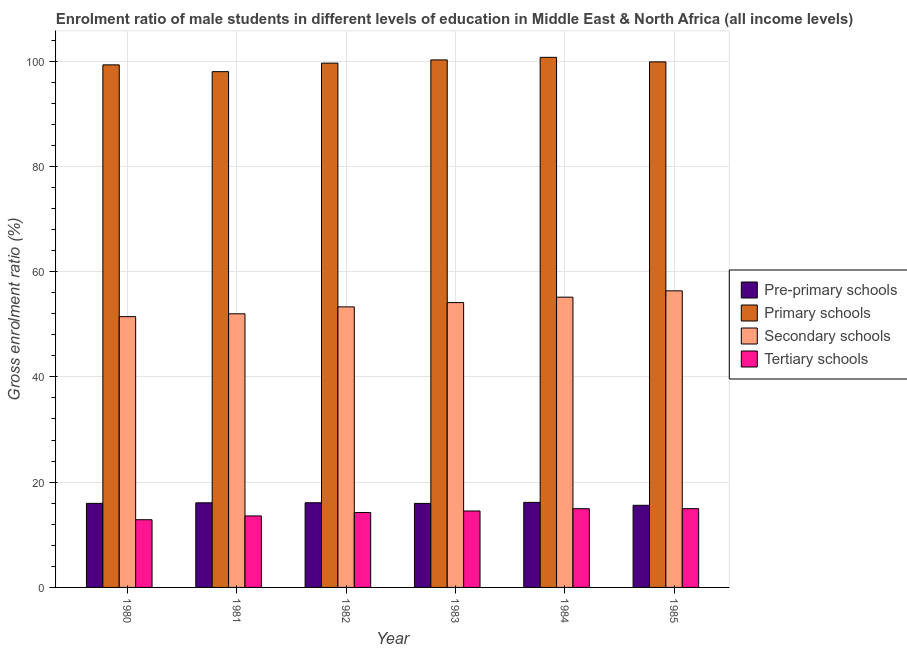How many different coloured bars are there?
Offer a terse response. 4. How many groups of bars are there?
Keep it short and to the point. 6. Are the number of bars on each tick of the X-axis equal?
Ensure brevity in your answer.  Yes. What is the gross enrolment ratio(female) in pre-primary schools in 1983?
Your answer should be very brief. 15.96. Across all years, what is the maximum gross enrolment ratio(female) in secondary schools?
Give a very brief answer. 56.35. Across all years, what is the minimum gross enrolment ratio(female) in pre-primary schools?
Your response must be concise. 15.6. In which year was the gross enrolment ratio(female) in primary schools maximum?
Give a very brief answer. 1984. In which year was the gross enrolment ratio(female) in pre-primary schools minimum?
Your answer should be very brief. 1985. What is the total gross enrolment ratio(female) in tertiary schools in the graph?
Your response must be concise. 85.13. What is the difference between the gross enrolment ratio(female) in tertiary schools in 1983 and that in 1984?
Your answer should be very brief. -0.43. What is the difference between the gross enrolment ratio(female) in tertiary schools in 1981 and the gross enrolment ratio(female) in secondary schools in 1982?
Give a very brief answer. -0.65. What is the average gross enrolment ratio(female) in primary schools per year?
Give a very brief answer. 99.61. In how many years, is the gross enrolment ratio(female) in primary schools greater than 52 %?
Your answer should be very brief. 6. What is the ratio of the gross enrolment ratio(female) in tertiary schools in 1980 to that in 1984?
Keep it short and to the point. 0.86. Is the gross enrolment ratio(female) in primary schools in 1984 less than that in 1985?
Provide a short and direct response. No. Is the difference between the gross enrolment ratio(female) in primary schools in 1983 and 1984 greater than the difference between the gross enrolment ratio(female) in pre-primary schools in 1983 and 1984?
Your response must be concise. No. What is the difference between the highest and the second highest gross enrolment ratio(female) in pre-primary schools?
Keep it short and to the point. 0.07. What is the difference between the highest and the lowest gross enrolment ratio(female) in secondary schools?
Your answer should be compact. 4.9. In how many years, is the gross enrolment ratio(female) in secondary schools greater than the average gross enrolment ratio(female) in secondary schools taken over all years?
Give a very brief answer. 3. Is the sum of the gross enrolment ratio(female) in primary schools in 1981 and 1985 greater than the maximum gross enrolment ratio(female) in tertiary schools across all years?
Provide a short and direct response. Yes. Is it the case that in every year, the sum of the gross enrolment ratio(female) in primary schools and gross enrolment ratio(female) in secondary schools is greater than the sum of gross enrolment ratio(female) in pre-primary schools and gross enrolment ratio(female) in tertiary schools?
Offer a terse response. No. What does the 2nd bar from the left in 1980 represents?
Give a very brief answer. Primary schools. What does the 2nd bar from the right in 1983 represents?
Make the answer very short. Secondary schools. Is it the case that in every year, the sum of the gross enrolment ratio(female) in pre-primary schools and gross enrolment ratio(female) in primary schools is greater than the gross enrolment ratio(female) in secondary schools?
Offer a terse response. Yes. What is the difference between two consecutive major ticks on the Y-axis?
Make the answer very short. 20. Are the values on the major ticks of Y-axis written in scientific E-notation?
Keep it short and to the point. No. Does the graph contain any zero values?
Make the answer very short. No. Where does the legend appear in the graph?
Give a very brief answer. Center right. What is the title of the graph?
Make the answer very short. Enrolment ratio of male students in different levels of education in Middle East & North Africa (all income levels). Does "Quality Certification" appear as one of the legend labels in the graph?
Your response must be concise. No. What is the Gross enrolment ratio (%) of Pre-primary schools in 1980?
Your answer should be compact. 15.97. What is the Gross enrolment ratio (%) in Primary schools in 1980?
Your answer should be very brief. 99.28. What is the Gross enrolment ratio (%) of Secondary schools in 1980?
Keep it short and to the point. 51.45. What is the Gross enrolment ratio (%) in Tertiary schools in 1980?
Provide a succinct answer. 12.86. What is the Gross enrolment ratio (%) of Pre-primary schools in 1981?
Give a very brief answer. 16.08. What is the Gross enrolment ratio (%) in Primary schools in 1981?
Provide a short and direct response. 97.99. What is the Gross enrolment ratio (%) of Secondary schools in 1981?
Keep it short and to the point. 51.98. What is the Gross enrolment ratio (%) in Tertiary schools in 1981?
Your answer should be very brief. 13.59. What is the Gross enrolment ratio (%) of Pre-primary schools in 1982?
Provide a short and direct response. 16.09. What is the Gross enrolment ratio (%) in Primary schools in 1982?
Offer a very short reply. 99.61. What is the Gross enrolment ratio (%) in Secondary schools in 1982?
Your answer should be very brief. 53.3. What is the Gross enrolment ratio (%) of Tertiary schools in 1982?
Provide a short and direct response. 14.24. What is the Gross enrolment ratio (%) of Pre-primary schools in 1983?
Make the answer very short. 15.96. What is the Gross enrolment ratio (%) of Primary schools in 1983?
Keep it short and to the point. 100.22. What is the Gross enrolment ratio (%) of Secondary schools in 1983?
Offer a terse response. 54.11. What is the Gross enrolment ratio (%) of Tertiary schools in 1983?
Give a very brief answer. 14.52. What is the Gross enrolment ratio (%) of Pre-primary schools in 1984?
Provide a short and direct response. 16.16. What is the Gross enrolment ratio (%) of Primary schools in 1984?
Offer a terse response. 100.71. What is the Gross enrolment ratio (%) in Secondary schools in 1984?
Offer a terse response. 55.15. What is the Gross enrolment ratio (%) of Tertiary schools in 1984?
Offer a very short reply. 14.96. What is the Gross enrolment ratio (%) in Pre-primary schools in 1985?
Keep it short and to the point. 15.6. What is the Gross enrolment ratio (%) of Primary schools in 1985?
Your response must be concise. 99.85. What is the Gross enrolment ratio (%) in Secondary schools in 1985?
Offer a terse response. 56.35. What is the Gross enrolment ratio (%) of Tertiary schools in 1985?
Offer a terse response. 14.96. Across all years, what is the maximum Gross enrolment ratio (%) in Pre-primary schools?
Ensure brevity in your answer.  16.16. Across all years, what is the maximum Gross enrolment ratio (%) in Primary schools?
Your answer should be compact. 100.71. Across all years, what is the maximum Gross enrolment ratio (%) of Secondary schools?
Give a very brief answer. 56.35. Across all years, what is the maximum Gross enrolment ratio (%) in Tertiary schools?
Your answer should be very brief. 14.96. Across all years, what is the minimum Gross enrolment ratio (%) in Pre-primary schools?
Keep it short and to the point. 15.6. Across all years, what is the minimum Gross enrolment ratio (%) of Primary schools?
Provide a succinct answer. 97.99. Across all years, what is the minimum Gross enrolment ratio (%) in Secondary schools?
Give a very brief answer. 51.45. Across all years, what is the minimum Gross enrolment ratio (%) of Tertiary schools?
Give a very brief answer. 12.86. What is the total Gross enrolment ratio (%) of Pre-primary schools in the graph?
Your answer should be very brief. 95.86. What is the total Gross enrolment ratio (%) of Primary schools in the graph?
Keep it short and to the point. 597.67. What is the total Gross enrolment ratio (%) in Secondary schools in the graph?
Offer a very short reply. 322.34. What is the total Gross enrolment ratio (%) of Tertiary schools in the graph?
Provide a short and direct response. 85.13. What is the difference between the Gross enrolment ratio (%) of Pre-primary schools in 1980 and that in 1981?
Your response must be concise. -0.1. What is the difference between the Gross enrolment ratio (%) in Primary schools in 1980 and that in 1981?
Offer a very short reply. 1.29. What is the difference between the Gross enrolment ratio (%) of Secondary schools in 1980 and that in 1981?
Offer a terse response. -0.54. What is the difference between the Gross enrolment ratio (%) in Tertiary schools in 1980 and that in 1981?
Provide a short and direct response. -0.72. What is the difference between the Gross enrolment ratio (%) in Pre-primary schools in 1980 and that in 1982?
Keep it short and to the point. -0.12. What is the difference between the Gross enrolment ratio (%) in Primary schools in 1980 and that in 1982?
Offer a very short reply. -0.33. What is the difference between the Gross enrolment ratio (%) in Secondary schools in 1980 and that in 1982?
Your response must be concise. -1.85. What is the difference between the Gross enrolment ratio (%) in Tertiary schools in 1980 and that in 1982?
Make the answer very short. -1.37. What is the difference between the Gross enrolment ratio (%) of Pre-primary schools in 1980 and that in 1983?
Give a very brief answer. 0.01. What is the difference between the Gross enrolment ratio (%) of Primary schools in 1980 and that in 1983?
Your answer should be compact. -0.94. What is the difference between the Gross enrolment ratio (%) in Secondary schools in 1980 and that in 1983?
Provide a short and direct response. -2.67. What is the difference between the Gross enrolment ratio (%) of Tertiary schools in 1980 and that in 1983?
Keep it short and to the point. -1.66. What is the difference between the Gross enrolment ratio (%) in Pre-primary schools in 1980 and that in 1984?
Give a very brief answer. -0.19. What is the difference between the Gross enrolment ratio (%) of Primary schools in 1980 and that in 1984?
Offer a very short reply. -1.43. What is the difference between the Gross enrolment ratio (%) in Secondary schools in 1980 and that in 1984?
Keep it short and to the point. -3.7. What is the difference between the Gross enrolment ratio (%) in Tertiary schools in 1980 and that in 1984?
Offer a very short reply. -2.09. What is the difference between the Gross enrolment ratio (%) in Pre-primary schools in 1980 and that in 1985?
Provide a short and direct response. 0.37. What is the difference between the Gross enrolment ratio (%) of Primary schools in 1980 and that in 1985?
Make the answer very short. -0.57. What is the difference between the Gross enrolment ratio (%) of Secondary schools in 1980 and that in 1985?
Offer a terse response. -4.9. What is the difference between the Gross enrolment ratio (%) in Tertiary schools in 1980 and that in 1985?
Your response must be concise. -2.1. What is the difference between the Gross enrolment ratio (%) in Pre-primary schools in 1981 and that in 1982?
Provide a short and direct response. -0.01. What is the difference between the Gross enrolment ratio (%) of Primary schools in 1981 and that in 1982?
Provide a short and direct response. -1.62. What is the difference between the Gross enrolment ratio (%) in Secondary schools in 1981 and that in 1982?
Provide a succinct answer. -1.32. What is the difference between the Gross enrolment ratio (%) of Tertiary schools in 1981 and that in 1982?
Ensure brevity in your answer.  -0.65. What is the difference between the Gross enrolment ratio (%) of Pre-primary schools in 1981 and that in 1983?
Keep it short and to the point. 0.11. What is the difference between the Gross enrolment ratio (%) of Primary schools in 1981 and that in 1983?
Keep it short and to the point. -2.23. What is the difference between the Gross enrolment ratio (%) of Secondary schools in 1981 and that in 1983?
Provide a short and direct response. -2.13. What is the difference between the Gross enrolment ratio (%) of Tertiary schools in 1981 and that in 1983?
Your answer should be very brief. -0.94. What is the difference between the Gross enrolment ratio (%) in Pre-primary schools in 1981 and that in 1984?
Give a very brief answer. -0.08. What is the difference between the Gross enrolment ratio (%) of Primary schools in 1981 and that in 1984?
Ensure brevity in your answer.  -2.72. What is the difference between the Gross enrolment ratio (%) of Secondary schools in 1981 and that in 1984?
Give a very brief answer. -3.16. What is the difference between the Gross enrolment ratio (%) of Tertiary schools in 1981 and that in 1984?
Make the answer very short. -1.37. What is the difference between the Gross enrolment ratio (%) of Pre-primary schools in 1981 and that in 1985?
Offer a very short reply. 0.47. What is the difference between the Gross enrolment ratio (%) of Primary schools in 1981 and that in 1985?
Your answer should be compact. -1.86. What is the difference between the Gross enrolment ratio (%) in Secondary schools in 1981 and that in 1985?
Ensure brevity in your answer.  -4.37. What is the difference between the Gross enrolment ratio (%) of Tertiary schools in 1981 and that in 1985?
Provide a succinct answer. -1.38. What is the difference between the Gross enrolment ratio (%) of Pre-primary schools in 1982 and that in 1983?
Ensure brevity in your answer.  0.13. What is the difference between the Gross enrolment ratio (%) of Primary schools in 1982 and that in 1983?
Give a very brief answer. -0.61. What is the difference between the Gross enrolment ratio (%) in Secondary schools in 1982 and that in 1983?
Keep it short and to the point. -0.81. What is the difference between the Gross enrolment ratio (%) of Tertiary schools in 1982 and that in 1983?
Make the answer very short. -0.28. What is the difference between the Gross enrolment ratio (%) in Pre-primary schools in 1982 and that in 1984?
Provide a short and direct response. -0.07. What is the difference between the Gross enrolment ratio (%) in Primary schools in 1982 and that in 1984?
Provide a succinct answer. -1.1. What is the difference between the Gross enrolment ratio (%) of Secondary schools in 1982 and that in 1984?
Offer a very short reply. -1.85. What is the difference between the Gross enrolment ratio (%) in Tertiary schools in 1982 and that in 1984?
Make the answer very short. -0.72. What is the difference between the Gross enrolment ratio (%) in Pre-primary schools in 1982 and that in 1985?
Offer a terse response. 0.48. What is the difference between the Gross enrolment ratio (%) in Primary schools in 1982 and that in 1985?
Give a very brief answer. -0.24. What is the difference between the Gross enrolment ratio (%) in Secondary schools in 1982 and that in 1985?
Offer a terse response. -3.05. What is the difference between the Gross enrolment ratio (%) in Tertiary schools in 1982 and that in 1985?
Your answer should be compact. -0.73. What is the difference between the Gross enrolment ratio (%) of Pre-primary schools in 1983 and that in 1984?
Make the answer very short. -0.2. What is the difference between the Gross enrolment ratio (%) in Primary schools in 1983 and that in 1984?
Make the answer very short. -0.49. What is the difference between the Gross enrolment ratio (%) in Secondary schools in 1983 and that in 1984?
Provide a short and direct response. -1.03. What is the difference between the Gross enrolment ratio (%) of Tertiary schools in 1983 and that in 1984?
Make the answer very short. -0.43. What is the difference between the Gross enrolment ratio (%) in Pre-primary schools in 1983 and that in 1985?
Keep it short and to the point. 0.36. What is the difference between the Gross enrolment ratio (%) in Primary schools in 1983 and that in 1985?
Ensure brevity in your answer.  0.37. What is the difference between the Gross enrolment ratio (%) of Secondary schools in 1983 and that in 1985?
Offer a very short reply. -2.24. What is the difference between the Gross enrolment ratio (%) of Tertiary schools in 1983 and that in 1985?
Offer a very short reply. -0.44. What is the difference between the Gross enrolment ratio (%) of Pre-primary schools in 1984 and that in 1985?
Your answer should be compact. 0.56. What is the difference between the Gross enrolment ratio (%) of Primary schools in 1984 and that in 1985?
Provide a succinct answer. 0.86. What is the difference between the Gross enrolment ratio (%) of Secondary schools in 1984 and that in 1985?
Your response must be concise. -1.2. What is the difference between the Gross enrolment ratio (%) of Tertiary schools in 1984 and that in 1985?
Provide a succinct answer. -0.01. What is the difference between the Gross enrolment ratio (%) in Pre-primary schools in 1980 and the Gross enrolment ratio (%) in Primary schools in 1981?
Keep it short and to the point. -82.02. What is the difference between the Gross enrolment ratio (%) of Pre-primary schools in 1980 and the Gross enrolment ratio (%) of Secondary schools in 1981?
Offer a terse response. -36.01. What is the difference between the Gross enrolment ratio (%) in Pre-primary schools in 1980 and the Gross enrolment ratio (%) in Tertiary schools in 1981?
Keep it short and to the point. 2.39. What is the difference between the Gross enrolment ratio (%) of Primary schools in 1980 and the Gross enrolment ratio (%) of Secondary schools in 1981?
Your response must be concise. 47.3. What is the difference between the Gross enrolment ratio (%) of Primary schools in 1980 and the Gross enrolment ratio (%) of Tertiary schools in 1981?
Your response must be concise. 85.69. What is the difference between the Gross enrolment ratio (%) in Secondary schools in 1980 and the Gross enrolment ratio (%) in Tertiary schools in 1981?
Make the answer very short. 37.86. What is the difference between the Gross enrolment ratio (%) in Pre-primary schools in 1980 and the Gross enrolment ratio (%) in Primary schools in 1982?
Your response must be concise. -83.64. What is the difference between the Gross enrolment ratio (%) of Pre-primary schools in 1980 and the Gross enrolment ratio (%) of Secondary schools in 1982?
Provide a succinct answer. -37.33. What is the difference between the Gross enrolment ratio (%) in Pre-primary schools in 1980 and the Gross enrolment ratio (%) in Tertiary schools in 1982?
Your answer should be compact. 1.73. What is the difference between the Gross enrolment ratio (%) in Primary schools in 1980 and the Gross enrolment ratio (%) in Secondary schools in 1982?
Provide a succinct answer. 45.98. What is the difference between the Gross enrolment ratio (%) in Primary schools in 1980 and the Gross enrolment ratio (%) in Tertiary schools in 1982?
Ensure brevity in your answer.  85.04. What is the difference between the Gross enrolment ratio (%) in Secondary schools in 1980 and the Gross enrolment ratio (%) in Tertiary schools in 1982?
Your response must be concise. 37.21. What is the difference between the Gross enrolment ratio (%) of Pre-primary schools in 1980 and the Gross enrolment ratio (%) of Primary schools in 1983?
Keep it short and to the point. -84.25. What is the difference between the Gross enrolment ratio (%) in Pre-primary schools in 1980 and the Gross enrolment ratio (%) in Secondary schools in 1983?
Your answer should be compact. -38.14. What is the difference between the Gross enrolment ratio (%) of Pre-primary schools in 1980 and the Gross enrolment ratio (%) of Tertiary schools in 1983?
Keep it short and to the point. 1.45. What is the difference between the Gross enrolment ratio (%) of Primary schools in 1980 and the Gross enrolment ratio (%) of Secondary schools in 1983?
Your answer should be very brief. 45.17. What is the difference between the Gross enrolment ratio (%) in Primary schools in 1980 and the Gross enrolment ratio (%) in Tertiary schools in 1983?
Your answer should be very brief. 84.76. What is the difference between the Gross enrolment ratio (%) of Secondary schools in 1980 and the Gross enrolment ratio (%) of Tertiary schools in 1983?
Ensure brevity in your answer.  36.92. What is the difference between the Gross enrolment ratio (%) of Pre-primary schools in 1980 and the Gross enrolment ratio (%) of Primary schools in 1984?
Make the answer very short. -84.74. What is the difference between the Gross enrolment ratio (%) in Pre-primary schools in 1980 and the Gross enrolment ratio (%) in Secondary schools in 1984?
Ensure brevity in your answer.  -39.18. What is the difference between the Gross enrolment ratio (%) in Pre-primary schools in 1980 and the Gross enrolment ratio (%) in Tertiary schools in 1984?
Provide a succinct answer. 1.01. What is the difference between the Gross enrolment ratio (%) in Primary schools in 1980 and the Gross enrolment ratio (%) in Secondary schools in 1984?
Provide a succinct answer. 44.13. What is the difference between the Gross enrolment ratio (%) in Primary schools in 1980 and the Gross enrolment ratio (%) in Tertiary schools in 1984?
Provide a succinct answer. 84.32. What is the difference between the Gross enrolment ratio (%) of Secondary schools in 1980 and the Gross enrolment ratio (%) of Tertiary schools in 1984?
Your response must be concise. 36.49. What is the difference between the Gross enrolment ratio (%) in Pre-primary schools in 1980 and the Gross enrolment ratio (%) in Primary schools in 1985?
Provide a short and direct response. -83.88. What is the difference between the Gross enrolment ratio (%) of Pre-primary schools in 1980 and the Gross enrolment ratio (%) of Secondary schools in 1985?
Your response must be concise. -40.38. What is the difference between the Gross enrolment ratio (%) in Pre-primary schools in 1980 and the Gross enrolment ratio (%) in Tertiary schools in 1985?
Your response must be concise. 1.01. What is the difference between the Gross enrolment ratio (%) of Primary schools in 1980 and the Gross enrolment ratio (%) of Secondary schools in 1985?
Make the answer very short. 42.93. What is the difference between the Gross enrolment ratio (%) in Primary schools in 1980 and the Gross enrolment ratio (%) in Tertiary schools in 1985?
Your response must be concise. 84.32. What is the difference between the Gross enrolment ratio (%) of Secondary schools in 1980 and the Gross enrolment ratio (%) of Tertiary schools in 1985?
Make the answer very short. 36.48. What is the difference between the Gross enrolment ratio (%) in Pre-primary schools in 1981 and the Gross enrolment ratio (%) in Primary schools in 1982?
Your response must be concise. -83.53. What is the difference between the Gross enrolment ratio (%) in Pre-primary schools in 1981 and the Gross enrolment ratio (%) in Secondary schools in 1982?
Ensure brevity in your answer.  -37.22. What is the difference between the Gross enrolment ratio (%) in Pre-primary schools in 1981 and the Gross enrolment ratio (%) in Tertiary schools in 1982?
Keep it short and to the point. 1.84. What is the difference between the Gross enrolment ratio (%) of Primary schools in 1981 and the Gross enrolment ratio (%) of Secondary schools in 1982?
Your answer should be very brief. 44.69. What is the difference between the Gross enrolment ratio (%) in Primary schools in 1981 and the Gross enrolment ratio (%) in Tertiary schools in 1982?
Your answer should be compact. 83.75. What is the difference between the Gross enrolment ratio (%) of Secondary schools in 1981 and the Gross enrolment ratio (%) of Tertiary schools in 1982?
Provide a succinct answer. 37.75. What is the difference between the Gross enrolment ratio (%) in Pre-primary schools in 1981 and the Gross enrolment ratio (%) in Primary schools in 1983?
Your response must be concise. -84.15. What is the difference between the Gross enrolment ratio (%) of Pre-primary schools in 1981 and the Gross enrolment ratio (%) of Secondary schools in 1983?
Your answer should be compact. -38.04. What is the difference between the Gross enrolment ratio (%) in Pre-primary schools in 1981 and the Gross enrolment ratio (%) in Tertiary schools in 1983?
Your answer should be compact. 1.55. What is the difference between the Gross enrolment ratio (%) of Primary schools in 1981 and the Gross enrolment ratio (%) of Secondary schools in 1983?
Offer a terse response. 43.88. What is the difference between the Gross enrolment ratio (%) of Primary schools in 1981 and the Gross enrolment ratio (%) of Tertiary schools in 1983?
Offer a terse response. 83.47. What is the difference between the Gross enrolment ratio (%) in Secondary schools in 1981 and the Gross enrolment ratio (%) in Tertiary schools in 1983?
Give a very brief answer. 37.46. What is the difference between the Gross enrolment ratio (%) in Pre-primary schools in 1981 and the Gross enrolment ratio (%) in Primary schools in 1984?
Provide a succinct answer. -84.64. What is the difference between the Gross enrolment ratio (%) in Pre-primary schools in 1981 and the Gross enrolment ratio (%) in Secondary schools in 1984?
Keep it short and to the point. -39.07. What is the difference between the Gross enrolment ratio (%) of Pre-primary schools in 1981 and the Gross enrolment ratio (%) of Tertiary schools in 1984?
Your answer should be very brief. 1.12. What is the difference between the Gross enrolment ratio (%) in Primary schools in 1981 and the Gross enrolment ratio (%) in Secondary schools in 1984?
Provide a short and direct response. 42.84. What is the difference between the Gross enrolment ratio (%) in Primary schools in 1981 and the Gross enrolment ratio (%) in Tertiary schools in 1984?
Offer a terse response. 83.03. What is the difference between the Gross enrolment ratio (%) in Secondary schools in 1981 and the Gross enrolment ratio (%) in Tertiary schools in 1984?
Provide a succinct answer. 37.03. What is the difference between the Gross enrolment ratio (%) of Pre-primary schools in 1981 and the Gross enrolment ratio (%) of Primary schools in 1985?
Your answer should be very brief. -83.77. What is the difference between the Gross enrolment ratio (%) in Pre-primary schools in 1981 and the Gross enrolment ratio (%) in Secondary schools in 1985?
Your answer should be very brief. -40.27. What is the difference between the Gross enrolment ratio (%) in Pre-primary schools in 1981 and the Gross enrolment ratio (%) in Tertiary schools in 1985?
Offer a terse response. 1.11. What is the difference between the Gross enrolment ratio (%) in Primary schools in 1981 and the Gross enrolment ratio (%) in Secondary schools in 1985?
Your answer should be very brief. 41.64. What is the difference between the Gross enrolment ratio (%) in Primary schools in 1981 and the Gross enrolment ratio (%) in Tertiary schools in 1985?
Your response must be concise. 83.03. What is the difference between the Gross enrolment ratio (%) in Secondary schools in 1981 and the Gross enrolment ratio (%) in Tertiary schools in 1985?
Make the answer very short. 37.02. What is the difference between the Gross enrolment ratio (%) in Pre-primary schools in 1982 and the Gross enrolment ratio (%) in Primary schools in 1983?
Offer a very short reply. -84.13. What is the difference between the Gross enrolment ratio (%) in Pre-primary schools in 1982 and the Gross enrolment ratio (%) in Secondary schools in 1983?
Your response must be concise. -38.02. What is the difference between the Gross enrolment ratio (%) of Pre-primary schools in 1982 and the Gross enrolment ratio (%) of Tertiary schools in 1983?
Provide a succinct answer. 1.57. What is the difference between the Gross enrolment ratio (%) of Primary schools in 1982 and the Gross enrolment ratio (%) of Secondary schools in 1983?
Make the answer very short. 45.5. What is the difference between the Gross enrolment ratio (%) of Primary schools in 1982 and the Gross enrolment ratio (%) of Tertiary schools in 1983?
Make the answer very short. 85.09. What is the difference between the Gross enrolment ratio (%) of Secondary schools in 1982 and the Gross enrolment ratio (%) of Tertiary schools in 1983?
Provide a short and direct response. 38.78. What is the difference between the Gross enrolment ratio (%) in Pre-primary schools in 1982 and the Gross enrolment ratio (%) in Primary schools in 1984?
Give a very brief answer. -84.62. What is the difference between the Gross enrolment ratio (%) in Pre-primary schools in 1982 and the Gross enrolment ratio (%) in Secondary schools in 1984?
Give a very brief answer. -39.06. What is the difference between the Gross enrolment ratio (%) in Pre-primary schools in 1982 and the Gross enrolment ratio (%) in Tertiary schools in 1984?
Provide a short and direct response. 1.13. What is the difference between the Gross enrolment ratio (%) of Primary schools in 1982 and the Gross enrolment ratio (%) of Secondary schools in 1984?
Your response must be concise. 44.46. What is the difference between the Gross enrolment ratio (%) in Primary schools in 1982 and the Gross enrolment ratio (%) in Tertiary schools in 1984?
Ensure brevity in your answer.  84.65. What is the difference between the Gross enrolment ratio (%) in Secondary schools in 1982 and the Gross enrolment ratio (%) in Tertiary schools in 1984?
Ensure brevity in your answer.  38.34. What is the difference between the Gross enrolment ratio (%) of Pre-primary schools in 1982 and the Gross enrolment ratio (%) of Primary schools in 1985?
Give a very brief answer. -83.76. What is the difference between the Gross enrolment ratio (%) of Pre-primary schools in 1982 and the Gross enrolment ratio (%) of Secondary schools in 1985?
Your answer should be compact. -40.26. What is the difference between the Gross enrolment ratio (%) in Pre-primary schools in 1982 and the Gross enrolment ratio (%) in Tertiary schools in 1985?
Make the answer very short. 1.13. What is the difference between the Gross enrolment ratio (%) in Primary schools in 1982 and the Gross enrolment ratio (%) in Secondary schools in 1985?
Offer a very short reply. 43.26. What is the difference between the Gross enrolment ratio (%) in Primary schools in 1982 and the Gross enrolment ratio (%) in Tertiary schools in 1985?
Your answer should be very brief. 84.65. What is the difference between the Gross enrolment ratio (%) in Secondary schools in 1982 and the Gross enrolment ratio (%) in Tertiary schools in 1985?
Provide a short and direct response. 38.34. What is the difference between the Gross enrolment ratio (%) in Pre-primary schools in 1983 and the Gross enrolment ratio (%) in Primary schools in 1984?
Your response must be concise. -84.75. What is the difference between the Gross enrolment ratio (%) in Pre-primary schools in 1983 and the Gross enrolment ratio (%) in Secondary schools in 1984?
Your answer should be compact. -39.19. What is the difference between the Gross enrolment ratio (%) of Pre-primary schools in 1983 and the Gross enrolment ratio (%) of Tertiary schools in 1984?
Your response must be concise. 1.01. What is the difference between the Gross enrolment ratio (%) in Primary schools in 1983 and the Gross enrolment ratio (%) in Secondary schools in 1984?
Your response must be concise. 45.08. What is the difference between the Gross enrolment ratio (%) of Primary schools in 1983 and the Gross enrolment ratio (%) of Tertiary schools in 1984?
Provide a succinct answer. 85.27. What is the difference between the Gross enrolment ratio (%) in Secondary schools in 1983 and the Gross enrolment ratio (%) in Tertiary schools in 1984?
Your answer should be very brief. 39.16. What is the difference between the Gross enrolment ratio (%) in Pre-primary schools in 1983 and the Gross enrolment ratio (%) in Primary schools in 1985?
Provide a short and direct response. -83.89. What is the difference between the Gross enrolment ratio (%) of Pre-primary schools in 1983 and the Gross enrolment ratio (%) of Secondary schools in 1985?
Your response must be concise. -40.39. What is the difference between the Gross enrolment ratio (%) in Primary schools in 1983 and the Gross enrolment ratio (%) in Secondary schools in 1985?
Make the answer very short. 43.87. What is the difference between the Gross enrolment ratio (%) in Primary schools in 1983 and the Gross enrolment ratio (%) in Tertiary schools in 1985?
Your answer should be very brief. 85.26. What is the difference between the Gross enrolment ratio (%) of Secondary schools in 1983 and the Gross enrolment ratio (%) of Tertiary schools in 1985?
Give a very brief answer. 39.15. What is the difference between the Gross enrolment ratio (%) of Pre-primary schools in 1984 and the Gross enrolment ratio (%) of Primary schools in 1985?
Give a very brief answer. -83.69. What is the difference between the Gross enrolment ratio (%) of Pre-primary schools in 1984 and the Gross enrolment ratio (%) of Secondary schools in 1985?
Provide a short and direct response. -40.19. What is the difference between the Gross enrolment ratio (%) in Pre-primary schools in 1984 and the Gross enrolment ratio (%) in Tertiary schools in 1985?
Offer a terse response. 1.2. What is the difference between the Gross enrolment ratio (%) in Primary schools in 1984 and the Gross enrolment ratio (%) in Secondary schools in 1985?
Give a very brief answer. 44.36. What is the difference between the Gross enrolment ratio (%) of Primary schools in 1984 and the Gross enrolment ratio (%) of Tertiary schools in 1985?
Your answer should be very brief. 85.75. What is the difference between the Gross enrolment ratio (%) of Secondary schools in 1984 and the Gross enrolment ratio (%) of Tertiary schools in 1985?
Offer a terse response. 40.18. What is the average Gross enrolment ratio (%) in Pre-primary schools per year?
Keep it short and to the point. 15.98. What is the average Gross enrolment ratio (%) of Primary schools per year?
Offer a terse response. 99.61. What is the average Gross enrolment ratio (%) of Secondary schools per year?
Your answer should be very brief. 53.72. What is the average Gross enrolment ratio (%) in Tertiary schools per year?
Keep it short and to the point. 14.19. In the year 1980, what is the difference between the Gross enrolment ratio (%) of Pre-primary schools and Gross enrolment ratio (%) of Primary schools?
Provide a short and direct response. -83.31. In the year 1980, what is the difference between the Gross enrolment ratio (%) of Pre-primary schools and Gross enrolment ratio (%) of Secondary schools?
Your answer should be very brief. -35.47. In the year 1980, what is the difference between the Gross enrolment ratio (%) in Pre-primary schools and Gross enrolment ratio (%) in Tertiary schools?
Provide a short and direct response. 3.11. In the year 1980, what is the difference between the Gross enrolment ratio (%) of Primary schools and Gross enrolment ratio (%) of Secondary schools?
Your answer should be very brief. 47.83. In the year 1980, what is the difference between the Gross enrolment ratio (%) in Primary schools and Gross enrolment ratio (%) in Tertiary schools?
Offer a very short reply. 86.42. In the year 1980, what is the difference between the Gross enrolment ratio (%) in Secondary schools and Gross enrolment ratio (%) in Tertiary schools?
Keep it short and to the point. 38.58. In the year 1981, what is the difference between the Gross enrolment ratio (%) of Pre-primary schools and Gross enrolment ratio (%) of Primary schools?
Give a very brief answer. -81.92. In the year 1981, what is the difference between the Gross enrolment ratio (%) of Pre-primary schools and Gross enrolment ratio (%) of Secondary schools?
Give a very brief answer. -35.91. In the year 1981, what is the difference between the Gross enrolment ratio (%) of Pre-primary schools and Gross enrolment ratio (%) of Tertiary schools?
Keep it short and to the point. 2.49. In the year 1981, what is the difference between the Gross enrolment ratio (%) of Primary schools and Gross enrolment ratio (%) of Secondary schools?
Offer a terse response. 46.01. In the year 1981, what is the difference between the Gross enrolment ratio (%) in Primary schools and Gross enrolment ratio (%) in Tertiary schools?
Your answer should be very brief. 84.41. In the year 1981, what is the difference between the Gross enrolment ratio (%) in Secondary schools and Gross enrolment ratio (%) in Tertiary schools?
Your answer should be very brief. 38.4. In the year 1982, what is the difference between the Gross enrolment ratio (%) of Pre-primary schools and Gross enrolment ratio (%) of Primary schools?
Provide a short and direct response. -83.52. In the year 1982, what is the difference between the Gross enrolment ratio (%) in Pre-primary schools and Gross enrolment ratio (%) in Secondary schools?
Make the answer very short. -37.21. In the year 1982, what is the difference between the Gross enrolment ratio (%) of Pre-primary schools and Gross enrolment ratio (%) of Tertiary schools?
Ensure brevity in your answer.  1.85. In the year 1982, what is the difference between the Gross enrolment ratio (%) of Primary schools and Gross enrolment ratio (%) of Secondary schools?
Ensure brevity in your answer.  46.31. In the year 1982, what is the difference between the Gross enrolment ratio (%) of Primary schools and Gross enrolment ratio (%) of Tertiary schools?
Your answer should be compact. 85.37. In the year 1982, what is the difference between the Gross enrolment ratio (%) in Secondary schools and Gross enrolment ratio (%) in Tertiary schools?
Provide a succinct answer. 39.06. In the year 1983, what is the difference between the Gross enrolment ratio (%) in Pre-primary schools and Gross enrolment ratio (%) in Primary schools?
Offer a terse response. -84.26. In the year 1983, what is the difference between the Gross enrolment ratio (%) of Pre-primary schools and Gross enrolment ratio (%) of Secondary schools?
Make the answer very short. -38.15. In the year 1983, what is the difference between the Gross enrolment ratio (%) of Pre-primary schools and Gross enrolment ratio (%) of Tertiary schools?
Provide a succinct answer. 1.44. In the year 1983, what is the difference between the Gross enrolment ratio (%) of Primary schools and Gross enrolment ratio (%) of Secondary schools?
Your response must be concise. 46.11. In the year 1983, what is the difference between the Gross enrolment ratio (%) in Primary schools and Gross enrolment ratio (%) in Tertiary schools?
Offer a very short reply. 85.7. In the year 1983, what is the difference between the Gross enrolment ratio (%) of Secondary schools and Gross enrolment ratio (%) of Tertiary schools?
Give a very brief answer. 39.59. In the year 1984, what is the difference between the Gross enrolment ratio (%) in Pre-primary schools and Gross enrolment ratio (%) in Primary schools?
Offer a terse response. -84.55. In the year 1984, what is the difference between the Gross enrolment ratio (%) of Pre-primary schools and Gross enrolment ratio (%) of Secondary schools?
Offer a terse response. -38.99. In the year 1984, what is the difference between the Gross enrolment ratio (%) in Pre-primary schools and Gross enrolment ratio (%) in Tertiary schools?
Your answer should be very brief. 1.2. In the year 1984, what is the difference between the Gross enrolment ratio (%) in Primary schools and Gross enrolment ratio (%) in Secondary schools?
Offer a terse response. 45.56. In the year 1984, what is the difference between the Gross enrolment ratio (%) in Primary schools and Gross enrolment ratio (%) in Tertiary schools?
Provide a succinct answer. 85.76. In the year 1984, what is the difference between the Gross enrolment ratio (%) of Secondary schools and Gross enrolment ratio (%) of Tertiary schools?
Provide a succinct answer. 40.19. In the year 1985, what is the difference between the Gross enrolment ratio (%) in Pre-primary schools and Gross enrolment ratio (%) in Primary schools?
Your answer should be very brief. -84.25. In the year 1985, what is the difference between the Gross enrolment ratio (%) in Pre-primary schools and Gross enrolment ratio (%) in Secondary schools?
Offer a very short reply. -40.75. In the year 1985, what is the difference between the Gross enrolment ratio (%) in Pre-primary schools and Gross enrolment ratio (%) in Tertiary schools?
Your answer should be compact. 0.64. In the year 1985, what is the difference between the Gross enrolment ratio (%) in Primary schools and Gross enrolment ratio (%) in Secondary schools?
Give a very brief answer. 43.5. In the year 1985, what is the difference between the Gross enrolment ratio (%) in Primary schools and Gross enrolment ratio (%) in Tertiary schools?
Give a very brief answer. 84.89. In the year 1985, what is the difference between the Gross enrolment ratio (%) of Secondary schools and Gross enrolment ratio (%) of Tertiary schools?
Provide a short and direct response. 41.39. What is the ratio of the Gross enrolment ratio (%) in Primary schools in 1980 to that in 1981?
Your answer should be compact. 1.01. What is the ratio of the Gross enrolment ratio (%) in Tertiary schools in 1980 to that in 1981?
Keep it short and to the point. 0.95. What is the ratio of the Gross enrolment ratio (%) in Secondary schools in 1980 to that in 1982?
Your response must be concise. 0.97. What is the ratio of the Gross enrolment ratio (%) of Tertiary schools in 1980 to that in 1982?
Your response must be concise. 0.9. What is the ratio of the Gross enrolment ratio (%) of Pre-primary schools in 1980 to that in 1983?
Offer a terse response. 1. What is the ratio of the Gross enrolment ratio (%) of Primary schools in 1980 to that in 1983?
Your response must be concise. 0.99. What is the ratio of the Gross enrolment ratio (%) in Secondary schools in 1980 to that in 1983?
Provide a short and direct response. 0.95. What is the ratio of the Gross enrolment ratio (%) in Tertiary schools in 1980 to that in 1983?
Your answer should be very brief. 0.89. What is the ratio of the Gross enrolment ratio (%) of Pre-primary schools in 1980 to that in 1984?
Keep it short and to the point. 0.99. What is the ratio of the Gross enrolment ratio (%) in Primary schools in 1980 to that in 1984?
Your response must be concise. 0.99. What is the ratio of the Gross enrolment ratio (%) of Secondary schools in 1980 to that in 1984?
Make the answer very short. 0.93. What is the ratio of the Gross enrolment ratio (%) in Tertiary schools in 1980 to that in 1984?
Your answer should be compact. 0.86. What is the ratio of the Gross enrolment ratio (%) in Pre-primary schools in 1980 to that in 1985?
Your answer should be compact. 1.02. What is the ratio of the Gross enrolment ratio (%) of Primary schools in 1980 to that in 1985?
Offer a terse response. 0.99. What is the ratio of the Gross enrolment ratio (%) in Tertiary schools in 1980 to that in 1985?
Offer a terse response. 0.86. What is the ratio of the Gross enrolment ratio (%) in Pre-primary schools in 1981 to that in 1982?
Provide a short and direct response. 1. What is the ratio of the Gross enrolment ratio (%) in Primary schools in 1981 to that in 1982?
Offer a terse response. 0.98. What is the ratio of the Gross enrolment ratio (%) in Secondary schools in 1981 to that in 1982?
Provide a short and direct response. 0.98. What is the ratio of the Gross enrolment ratio (%) of Tertiary schools in 1981 to that in 1982?
Your answer should be compact. 0.95. What is the ratio of the Gross enrolment ratio (%) of Pre-primary schools in 1981 to that in 1983?
Offer a terse response. 1.01. What is the ratio of the Gross enrolment ratio (%) of Primary schools in 1981 to that in 1983?
Your answer should be compact. 0.98. What is the ratio of the Gross enrolment ratio (%) in Secondary schools in 1981 to that in 1983?
Provide a succinct answer. 0.96. What is the ratio of the Gross enrolment ratio (%) of Tertiary schools in 1981 to that in 1983?
Your answer should be very brief. 0.94. What is the ratio of the Gross enrolment ratio (%) of Pre-primary schools in 1981 to that in 1984?
Ensure brevity in your answer.  0.99. What is the ratio of the Gross enrolment ratio (%) of Secondary schools in 1981 to that in 1984?
Ensure brevity in your answer.  0.94. What is the ratio of the Gross enrolment ratio (%) in Tertiary schools in 1981 to that in 1984?
Your answer should be very brief. 0.91. What is the ratio of the Gross enrolment ratio (%) of Pre-primary schools in 1981 to that in 1985?
Your answer should be compact. 1.03. What is the ratio of the Gross enrolment ratio (%) in Primary schools in 1981 to that in 1985?
Your answer should be compact. 0.98. What is the ratio of the Gross enrolment ratio (%) of Secondary schools in 1981 to that in 1985?
Offer a very short reply. 0.92. What is the ratio of the Gross enrolment ratio (%) in Tertiary schools in 1981 to that in 1985?
Offer a very short reply. 0.91. What is the ratio of the Gross enrolment ratio (%) of Pre-primary schools in 1982 to that in 1983?
Provide a short and direct response. 1.01. What is the ratio of the Gross enrolment ratio (%) in Secondary schools in 1982 to that in 1983?
Offer a very short reply. 0.98. What is the ratio of the Gross enrolment ratio (%) of Tertiary schools in 1982 to that in 1983?
Give a very brief answer. 0.98. What is the ratio of the Gross enrolment ratio (%) of Primary schools in 1982 to that in 1984?
Your response must be concise. 0.99. What is the ratio of the Gross enrolment ratio (%) of Secondary schools in 1982 to that in 1984?
Provide a succinct answer. 0.97. What is the ratio of the Gross enrolment ratio (%) of Tertiary schools in 1982 to that in 1984?
Make the answer very short. 0.95. What is the ratio of the Gross enrolment ratio (%) in Pre-primary schools in 1982 to that in 1985?
Make the answer very short. 1.03. What is the ratio of the Gross enrolment ratio (%) in Primary schools in 1982 to that in 1985?
Give a very brief answer. 1. What is the ratio of the Gross enrolment ratio (%) of Secondary schools in 1982 to that in 1985?
Ensure brevity in your answer.  0.95. What is the ratio of the Gross enrolment ratio (%) of Tertiary schools in 1982 to that in 1985?
Offer a terse response. 0.95. What is the ratio of the Gross enrolment ratio (%) of Primary schools in 1983 to that in 1984?
Ensure brevity in your answer.  1. What is the ratio of the Gross enrolment ratio (%) of Secondary schools in 1983 to that in 1984?
Ensure brevity in your answer.  0.98. What is the ratio of the Gross enrolment ratio (%) of Tertiary schools in 1983 to that in 1984?
Offer a terse response. 0.97. What is the ratio of the Gross enrolment ratio (%) in Pre-primary schools in 1983 to that in 1985?
Give a very brief answer. 1.02. What is the ratio of the Gross enrolment ratio (%) in Secondary schools in 1983 to that in 1985?
Provide a short and direct response. 0.96. What is the ratio of the Gross enrolment ratio (%) in Tertiary schools in 1983 to that in 1985?
Your answer should be compact. 0.97. What is the ratio of the Gross enrolment ratio (%) in Pre-primary schools in 1984 to that in 1985?
Your answer should be compact. 1.04. What is the ratio of the Gross enrolment ratio (%) of Primary schools in 1984 to that in 1985?
Give a very brief answer. 1.01. What is the ratio of the Gross enrolment ratio (%) in Secondary schools in 1984 to that in 1985?
Offer a very short reply. 0.98. What is the difference between the highest and the second highest Gross enrolment ratio (%) in Pre-primary schools?
Offer a very short reply. 0.07. What is the difference between the highest and the second highest Gross enrolment ratio (%) of Primary schools?
Offer a terse response. 0.49. What is the difference between the highest and the second highest Gross enrolment ratio (%) in Secondary schools?
Ensure brevity in your answer.  1.2. What is the difference between the highest and the second highest Gross enrolment ratio (%) in Tertiary schools?
Your answer should be compact. 0.01. What is the difference between the highest and the lowest Gross enrolment ratio (%) in Pre-primary schools?
Your response must be concise. 0.56. What is the difference between the highest and the lowest Gross enrolment ratio (%) of Primary schools?
Your response must be concise. 2.72. What is the difference between the highest and the lowest Gross enrolment ratio (%) in Secondary schools?
Provide a short and direct response. 4.9. What is the difference between the highest and the lowest Gross enrolment ratio (%) in Tertiary schools?
Your answer should be compact. 2.1. 